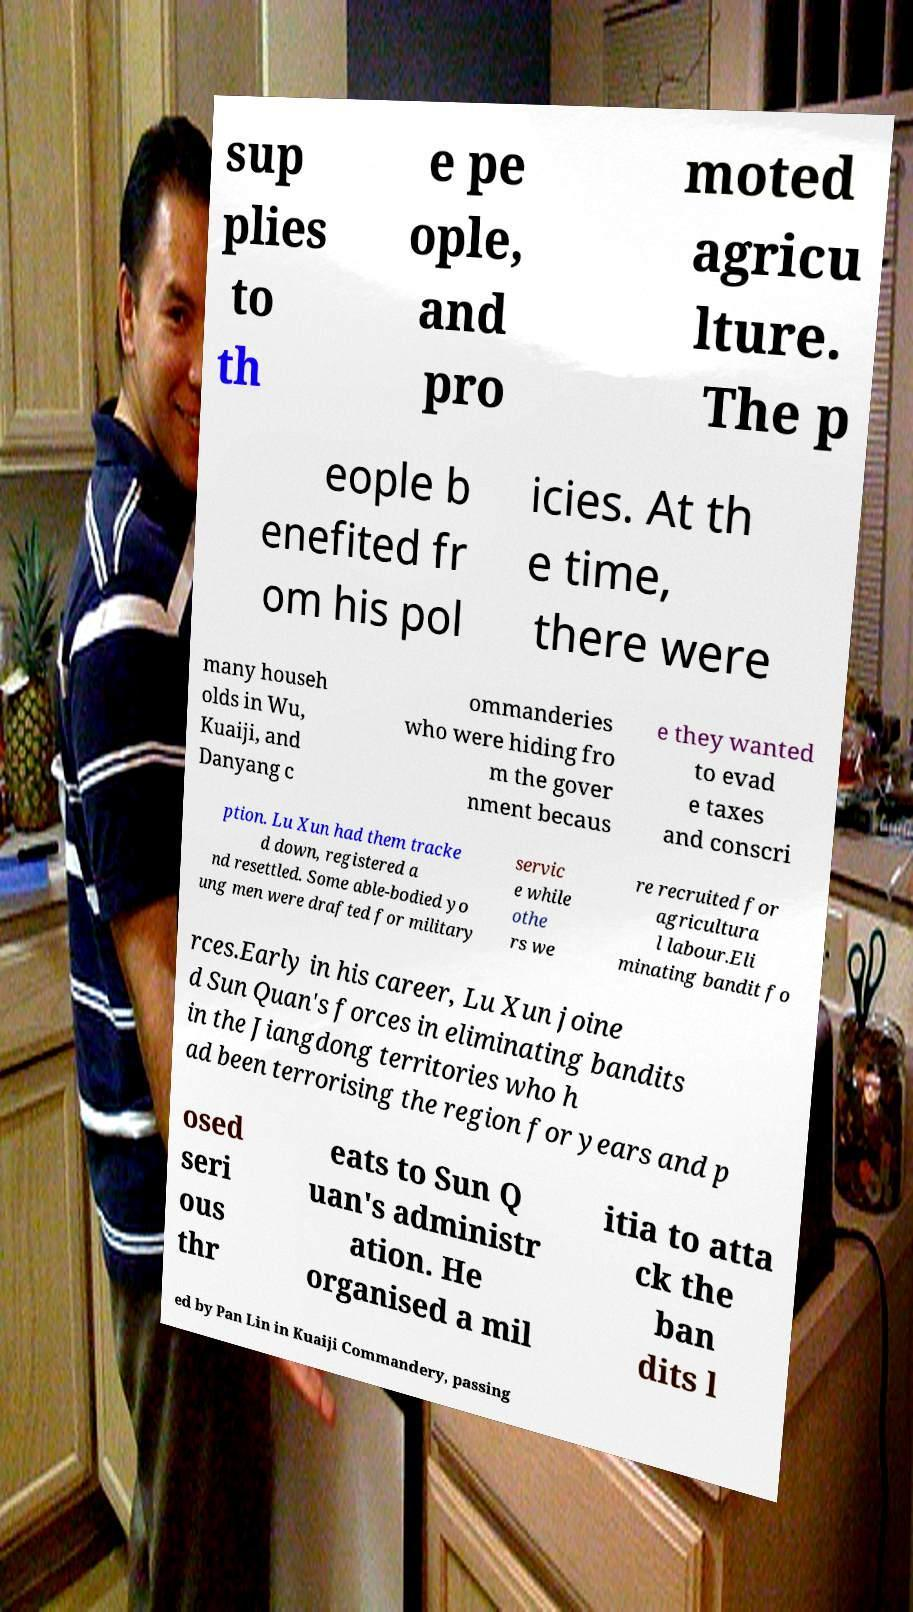Please identify and transcribe the text found in this image. sup plies to th e pe ople, and pro moted agricu lture. The p eople b enefited fr om his pol icies. At th e time, there were many househ olds in Wu, Kuaiji, and Danyang c ommanderies who were hiding fro m the gover nment becaus e they wanted to evad e taxes and conscri ption. Lu Xun had them tracke d down, registered a nd resettled. Some able-bodied yo ung men were drafted for military servic e while othe rs we re recruited for agricultura l labour.Eli minating bandit fo rces.Early in his career, Lu Xun joine d Sun Quan's forces in eliminating bandits in the Jiangdong territories who h ad been terrorising the region for years and p osed seri ous thr eats to Sun Q uan's administr ation. He organised a mil itia to atta ck the ban dits l ed by Pan Lin in Kuaiji Commandery, passing 